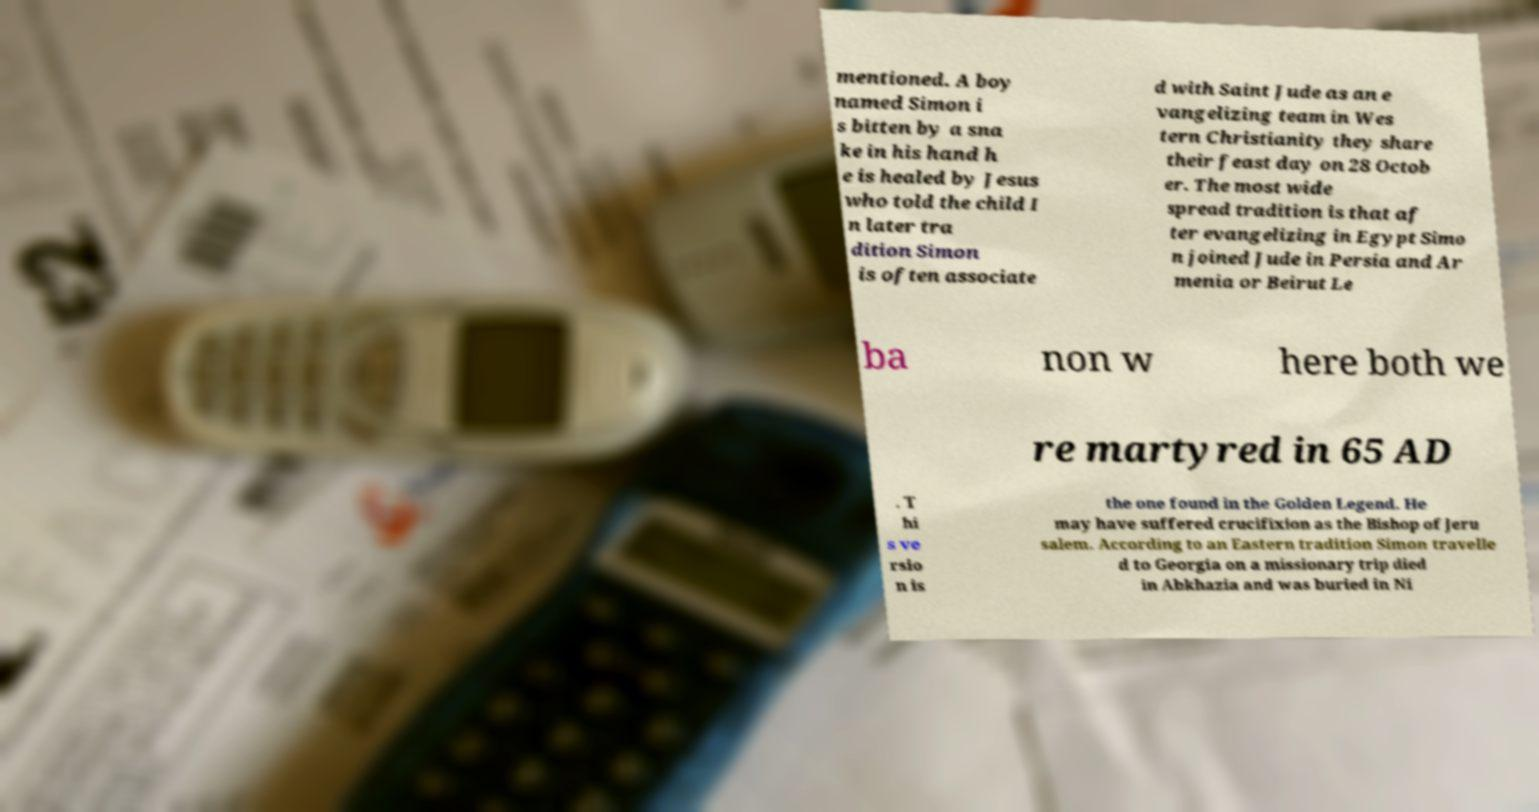Could you assist in decoding the text presented in this image and type it out clearly? mentioned. A boy named Simon i s bitten by a sna ke in his hand h e is healed by Jesus who told the child I n later tra dition Simon is often associate d with Saint Jude as an e vangelizing team in Wes tern Christianity they share their feast day on 28 Octob er. The most wide spread tradition is that af ter evangelizing in Egypt Simo n joined Jude in Persia and Ar menia or Beirut Le ba non w here both we re martyred in 65 AD . T hi s ve rsio n is the one found in the Golden Legend. He may have suffered crucifixion as the Bishop of Jeru salem. According to an Eastern tradition Simon travelle d to Georgia on a missionary trip died in Abkhazia and was buried in Ni 